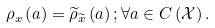Convert formula to latex. <formula><loc_0><loc_0><loc_500><loc_500>\rho _ { x } \left ( a \right ) = \widetilde { \rho } _ { \widetilde { x } } \left ( a \right ) ; \forall a \in C \left ( \mathcal { X } \right ) .</formula> 